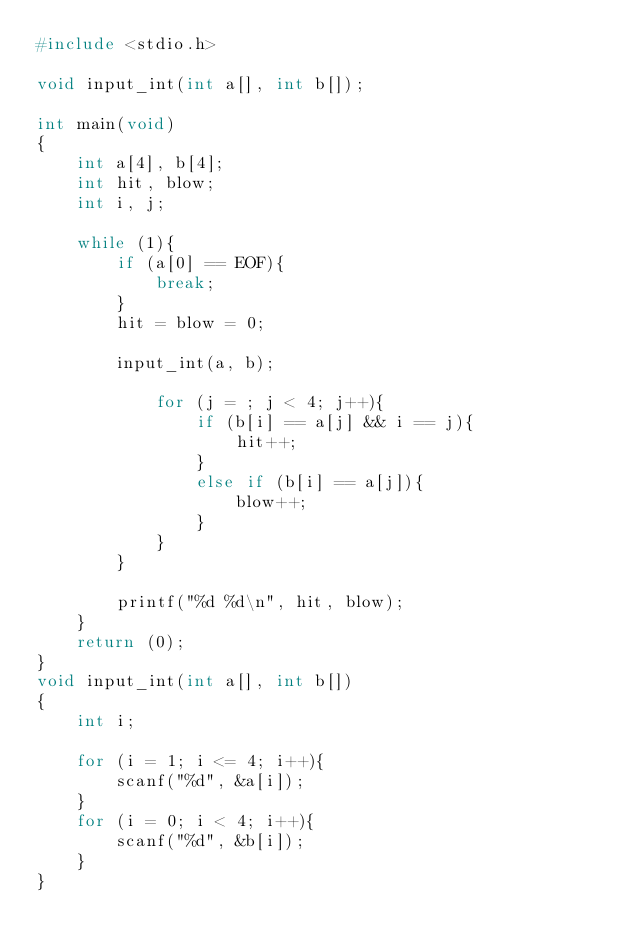<code> <loc_0><loc_0><loc_500><loc_500><_C_>#include <stdio.h>

void input_int(int a[], int b[]);

int main(void)
{
	int a[4], b[4];
	int hit, blow;
	int i, j;
	
	while (1){
		if (a[0] == EOF){
			break;
		}
		hit = blow = 0;
	
		input_int(a, b);
	
 			for (j = ; j < 4; j++){
				if (b[i] == a[j] && i == j){
					hit++;
				}
				else if (b[i] == a[j]){
					blow++;
				}
			}
		}
	
		printf("%d %d\n", hit, blow);
	}
	return (0);
}
void input_int(int a[], int b[])
{
	int i;
	
	for (i = 1; i <= 4; i++){
		scanf("%d", &a[i]);
	}
	for (i = 0; i < 4; i++){
		scanf("%d", &b[i]);
	}
}</code> 